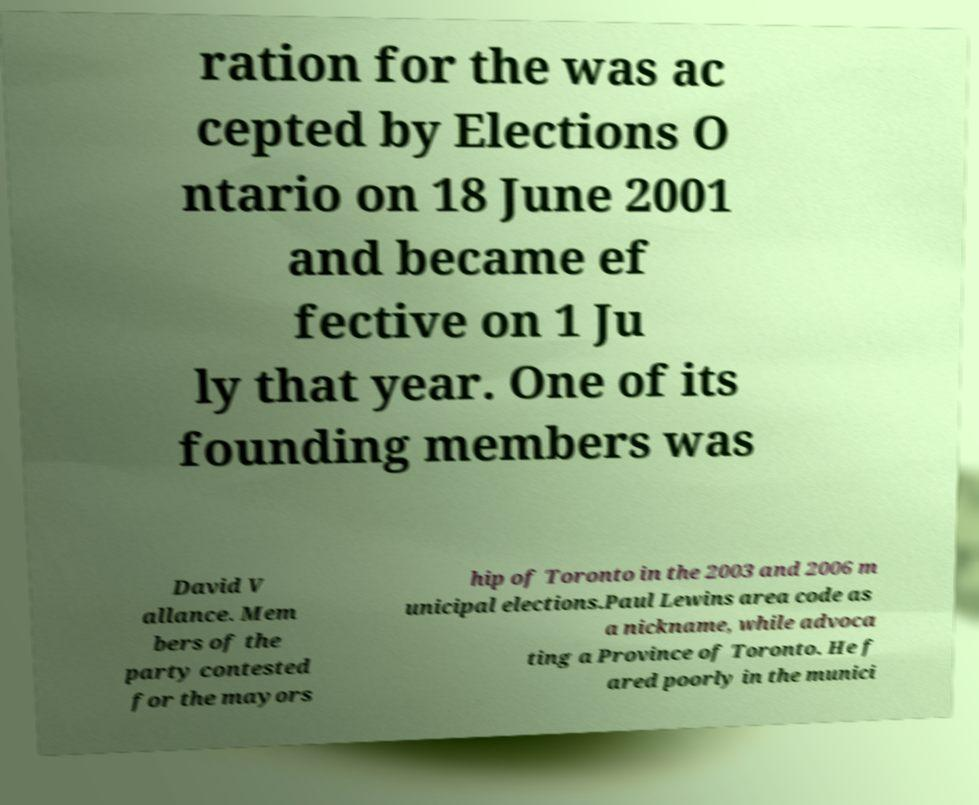Could you assist in decoding the text presented in this image and type it out clearly? ration for the was ac cepted by Elections O ntario on 18 June 2001 and became ef fective on 1 Ju ly that year. One of its founding members was David V allance. Mem bers of the party contested for the mayors hip of Toronto in the 2003 and 2006 m unicipal elections.Paul Lewins area code as a nickname, while advoca ting a Province of Toronto. He f ared poorly in the munici 